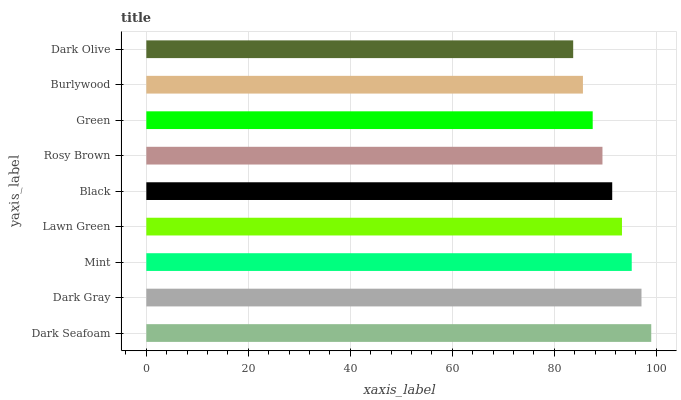Is Dark Olive the minimum?
Answer yes or no. Yes. Is Dark Seafoam the maximum?
Answer yes or no. Yes. Is Dark Gray the minimum?
Answer yes or no. No. Is Dark Gray the maximum?
Answer yes or no. No. Is Dark Seafoam greater than Dark Gray?
Answer yes or no. Yes. Is Dark Gray less than Dark Seafoam?
Answer yes or no. Yes. Is Dark Gray greater than Dark Seafoam?
Answer yes or no. No. Is Dark Seafoam less than Dark Gray?
Answer yes or no. No. Is Black the high median?
Answer yes or no. Yes. Is Black the low median?
Answer yes or no. Yes. Is Burlywood the high median?
Answer yes or no. No. Is Green the low median?
Answer yes or no. No. 